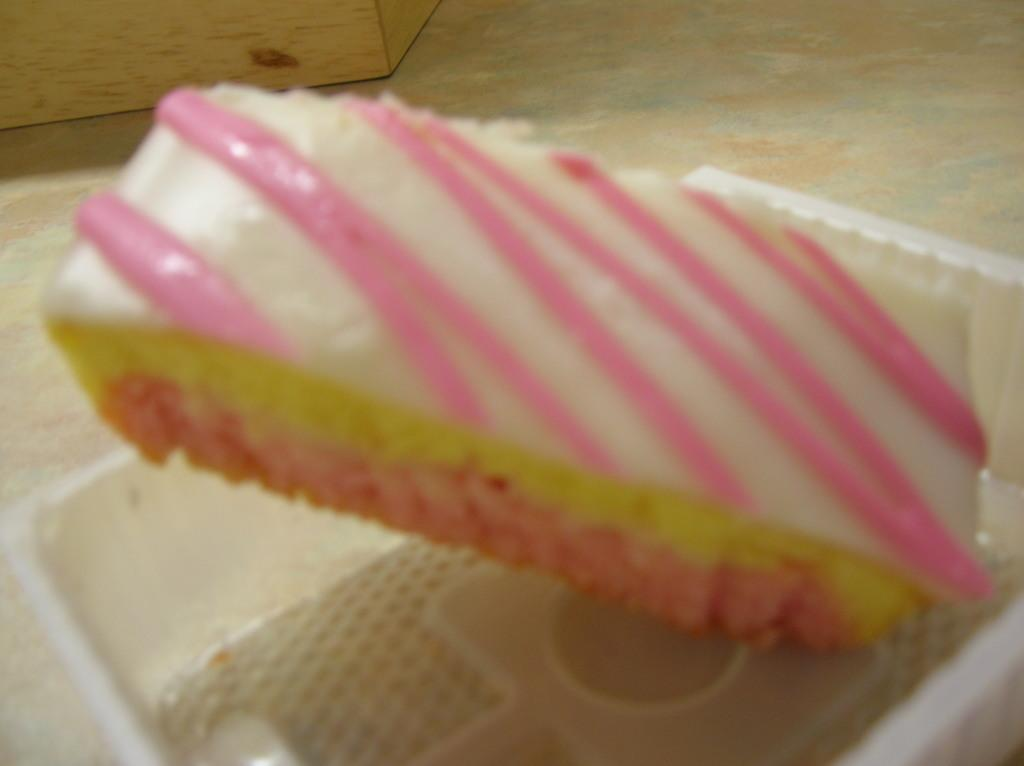What type of container is visible in the image? There is a plastic container in the image. What is stored inside the container? Food items are kept in the plastic container. Where is the plastic container placed? The plastic container is placed on a surface. What can be seen in the background of the image? There is a wooden object in the background of the image. How much liquid is present in the cave depicted in the image? There is no cave present in the image, and therefore no liquid can be observed in a cave. 